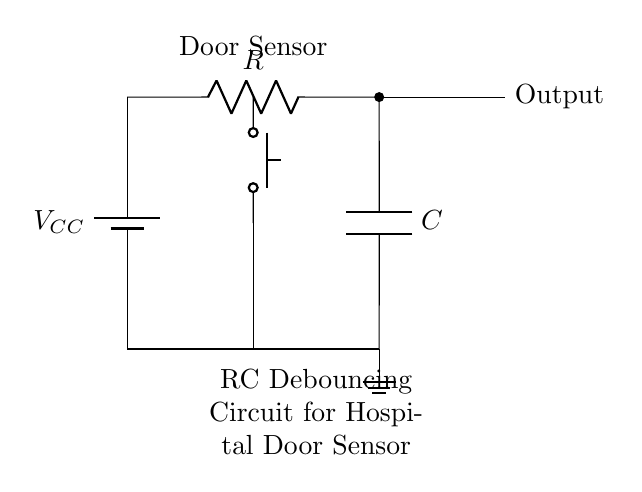What is the value of the capacitor in this circuit? The diagram labels the capacitor as C, but it does not provide a specific value. Therefore, the value remains generic.
Answer: C What type of switch is used in the circuit? The circuit diagram indicates the switch type as a push button, which can be confirmed by the symbol used in the diagram.
Answer: Push button What is the purpose of the resistor in this circuit? The resistor in an RC circuit helps to control the charging and discharging rates of the capacitor, which is crucial for debouncing.
Answer: Debouncing What is the output connection labeled as? The output connection in the circuit is clearly labeled as "Output," making it easy to identify where the processed signal will be sent.
Answer: Output How does the RC time constant affect the circuit operation? The RC time constant, which is the product of the resistance R and capacitance C, determines how quickly the capacitor charges and discharges. This affects the responsiveness of the sensor to switch noise, ensuring that only clean signals pass through during transitions.
Answer: It determines responsiveness What happens when the door sensor is activated? When the door sensor is activated (pressed), the current flows through the circuit, charging the capacitor. The resistor controls the current flow, preventing quick fluctuations (bounce) from affecting the output. As the capacitor charges, it smooths out the signal resulting in a stable output.
Answer: The capacitor charges 